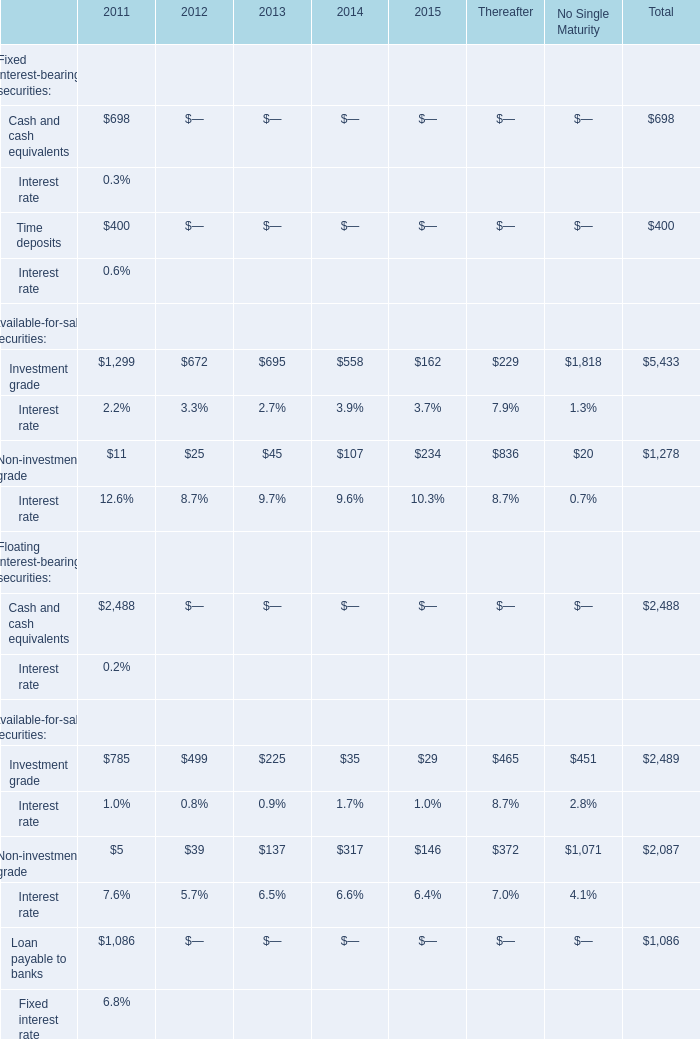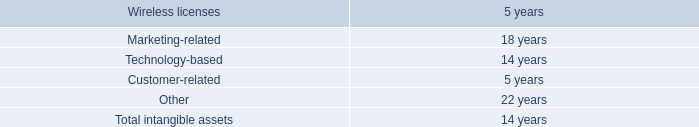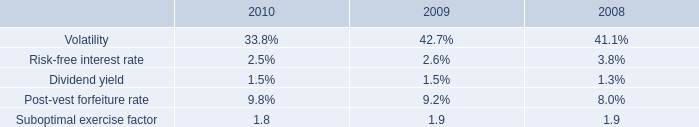What is the sum of the Investment grade in the years where Investment grade is positive? 
Computations: ((((1299 + 672) + 695) + 558) + 162)
Answer: 3386.0. 